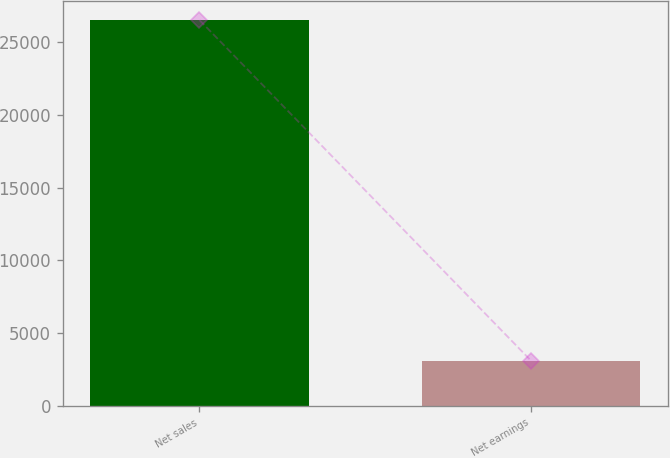<chart> <loc_0><loc_0><loc_500><loc_500><bar_chart><fcel>Net sales<fcel>Net earnings<nl><fcel>26536<fcel>3109<nl></chart> 